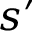Convert formula to latex. <formula><loc_0><loc_0><loc_500><loc_500>s ^ { \prime }</formula> 